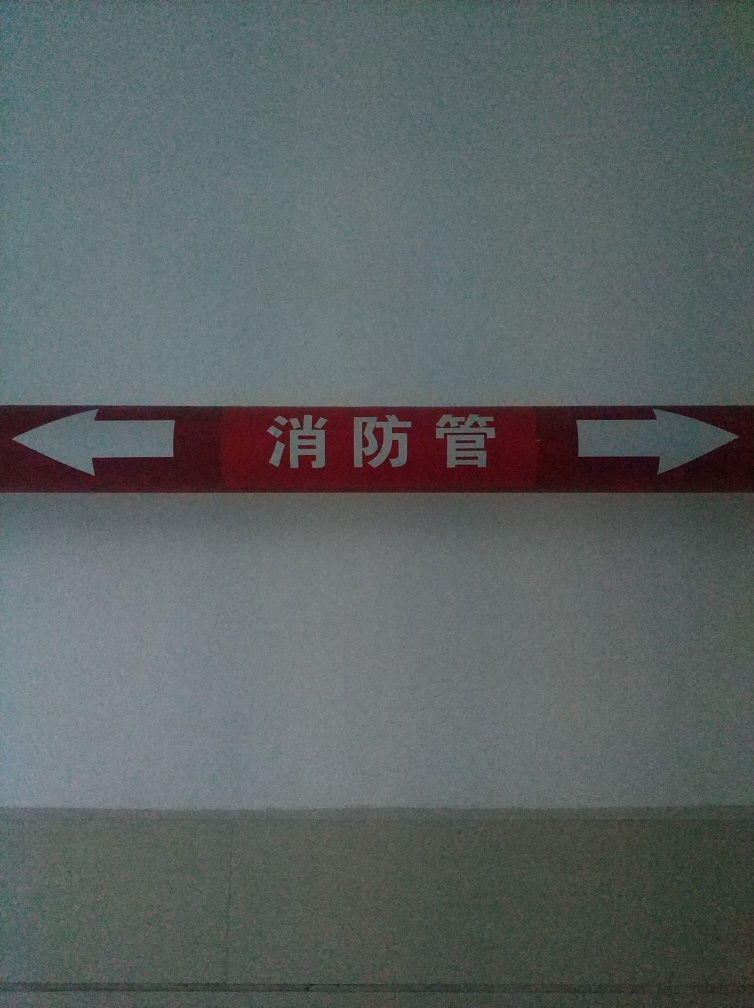What can you say about the symbolism of the arrow signs in the image? The arrow signs in the image indicate direction, likely serving as a guide for navigation. Their contrasting color and prominent size ensure they are easily noticeable, which can efficiently direct viewers' movement to the intended paths, symbolizing guidance and directionality in physical spaces. 